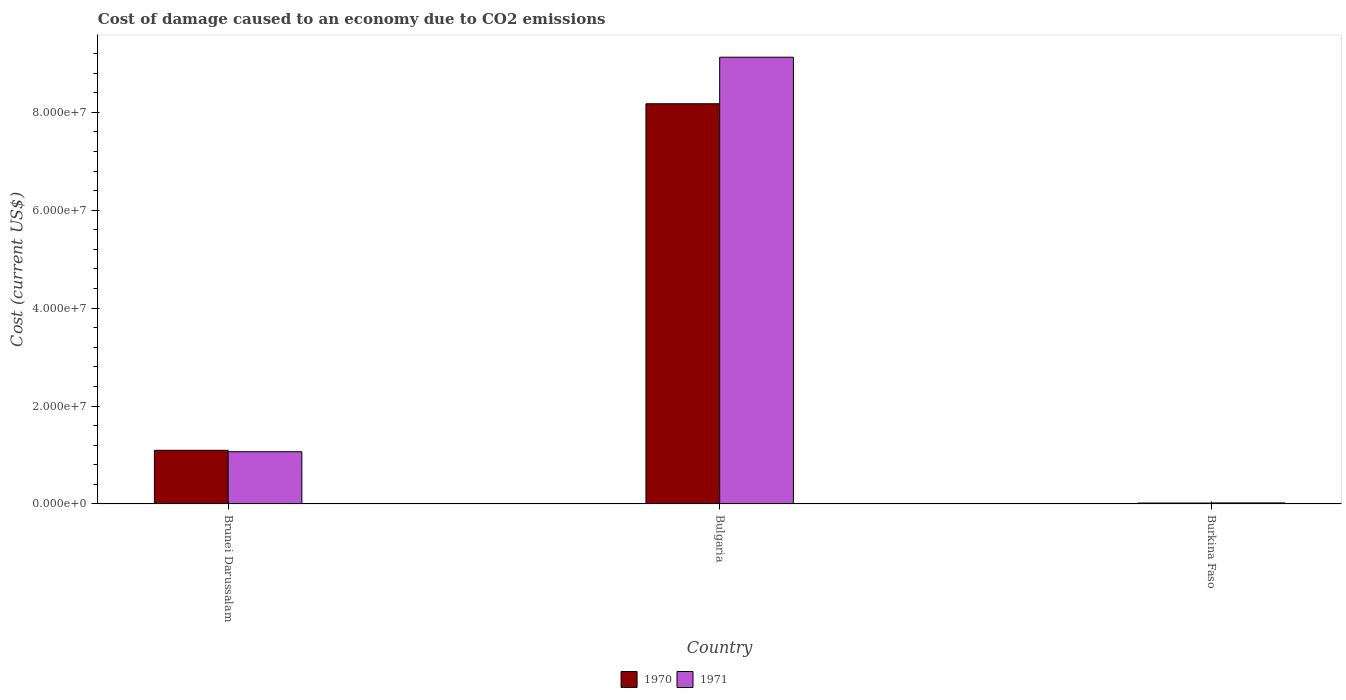What is the label of the 3rd group of bars from the left?
Provide a short and direct response. Burkina Faso. In how many cases, is the number of bars for a given country not equal to the number of legend labels?
Provide a succinct answer. 0. What is the cost of damage caused due to CO2 emissisons in 1971 in Bulgaria?
Give a very brief answer. 9.12e+07. Across all countries, what is the maximum cost of damage caused due to CO2 emissisons in 1970?
Offer a very short reply. 8.17e+07. Across all countries, what is the minimum cost of damage caused due to CO2 emissisons in 1970?
Make the answer very short. 1.91e+05. In which country was the cost of damage caused due to CO2 emissisons in 1971 minimum?
Give a very brief answer. Burkina Faso. What is the total cost of damage caused due to CO2 emissisons in 1971 in the graph?
Offer a terse response. 1.02e+08. What is the difference between the cost of damage caused due to CO2 emissisons in 1971 in Brunei Darussalam and that in Burkina Faso?
Provide a succinct answer. 1.05e+07. What is the difference between the cost of damage caused due to CO2 emissisons in 1971 in Brunei Darussalam and the cost of damage caused due to CO2 emissisons in 1970 in Bulgaria?
Make the answer very short. -7.11e+07. What is the average cost of damage caused due to CO2 emissisons in 1971 per country?
Provide a succinct answer. 3.40e+07. What is the difference between the cost of damage caused due to CO2 emissisons of/in 1970 and cost of damage caused due to CO2 emissisons of/in 1971 in Bulgaria?
Your answer should be very brief. -9.51e+06. What is the ratio of the cost of damage caused due to CO2 emissisons in 1971 in Bulgaria to that in Burkina Faso?
Provide a short and direct response. 427.68. What is the difference between the highest and the second highest cost of damage caused due to CO2 emissisons in 1971?
Your answer should be compact. 8.06e+07. What is the difference between the highest and the lowest cost of damage caused due to CO2 emissisons in 1970?
Offer a terse response. 8.16e+07. Is the sum of the cost of damage caused due to CO2 emissisons in 1970 in Bulgaria and Burkina Faso greater than the maximum cost of damage caused due to CO2 emissisons in 1971 across all countries?
Keep it short and to the point. No. What does the 2nd bar from the right in Brunei Darussalam represents?
Ensure brevity in your answer.  1970. How many bars are there?
Your answer should be compact. 6. What is the difference between two consecutive major ticks on the Y-axis?
Provide a short and direct response. 2.00e+07. Does the graph contain grids?
Your answer should be very brief. No. Where does the legend appear in the graph?
Make the answer very short. Bottom center. How are the legend labels stacked?
Make the answer very short. Horizontal. What is the title of the graph?
Offer a terse response. Cost of damage caused to an economy due to CO2 emissions. What is the label or title of the X-axis?
Your response must be concise. Country. What is the label or title of the Y-axis?
Make the answer very short. Cost (current US$). What is the Cost (current US$) of 1970 in Brunei Darussalam?
Keep it short and to the point. 1.10e+07. What is the Cost (current US$) of 1971 in Brunei Darussalam?
Ensure brevity in your answer.  1.07e+07. What is the Cost (current US$) in 1970 in Bulgaria?
Give a very brief answer. 8.17e+07. What is the Cost (current US$) of 1971 in Bulgaria?
Keep it short and to the point. 9.12e+07. What is the Cost (current US$) in 1970 in Burkina Faso?
Make the answer very short. 1.91e+05. What is the Cost (current US$) of 1971 in Burkina Faso?
Keep it short and to the point. 2.13e+05. Across all countries, what is the maximum Cost (current US$) of 1970?
Give a very brief answer. 8.17e+07. Across all countries, what is the maximum Cost (current US$) in 1971?
Provide a short and direct response. 9.12e+07. Across all countries, what is the minimum Cost (current US$) in 1970?
Give a very brief answer. 1.91e+05. Across all countries, what is the minimum Cost (current US$) of 1971?
Keep it short and to the point. 2.13e+05. What is the total Cost (current US$) of 1970 in the graph?
Your answer should be compact. 9.29e+07. What is the total Cost (current US$) of 1971 in the graph?
Make the answer very short. 1.02e+08. What is the difference between the Cost (current US$) of 1970 in Brunei Darussalam and that in Bulgaria?
Your response must be concise. -7.08e+07. What is the difference between the Cost (current US$) of 1971 in Brunei Darussalam and that in Bulgaria?
Offer a very short reply. -8.06e+07. What is the difference between the Cost (current US$) in 1970 in Brunei Darussalam and that in Burkina Faso?
Provide a succinct answer. 1.08e+07. What is the difference between the Cost (current US$) in 1971 in Brunei Darussalam and that in Burkina Faso?
Your response must be concise. 1.05e+07. What is the difference between the Cost (current US$) in 1970 in Bulgaria and that in Burkina Faso?
Your answer should be very brief. 8.16e+07. What is the difference between the Cost (current US$) in 1971 in Bulgaria and that in Burkina Faso?
Your response must be concise. 9.10e+07. What is the difference between the Cost (current US$) of 1970 in Brunei Darussalam and the Cost (current US$) of 1971 in Bulgaria?
Your answer should be compact. -8.03e+07. What is the difference between the Cost (current US$) in 1970 in Brunei Darussalam and the Cost (current US$) in 1971 in Burkina Faso?
Provide a short and direct response. 1.07e+07. What is the difference between the Cost (current US$) of 1970 in Bulgaria and the Cost (current US$) of 1971 in Burkina Faso?
Your answer should be compact. 8.15e+07. What is the average Cost (current US$) in 1970 per country?
Ensure brevity in your answer.  3.10e+07. What is the average Cost (current US$) in 1971 per country?
Offer a very short reply. 3.40e+07. What is the difference between the Cost (current US$) of 1970 and Cost (current US$) of 1971 in Brunei Darussalam?
Your answer should be very brief. 2.92e+05. What is the difference between the Cost (current US$) of 1970 and Cost (current US$) of 1971 in Bulgaria?
Your answer should be compact. -9.51e+06. What is the difference between the Cost (current US$) in 1970 and Cost (current US$) in 1971 in Burkina Faso?
Your answer should be very brief. -2.25e+04. What is the ratio of the Cost (current US$) of 1970 in Brunei Darussalam to that in Bulgaria?
Give a very brief answer. 0.13. What is the ratio of the Cost (current US$) in 1971 in Brunei Darussalam to that in Bulgaria?
Your answer should be compact. 0.12. What is the ratio of the Cost (current US$) in 1970 in Brunei Darussalam to that in Burkina Faso?
Your answer should be compact. 57.41. What is the ratio of the Cost (current US$) of 1971 in Brunei Darussalam to that in Burkina Faso?
Make the answer very short. 50. What is the ratio of the Cost (current US$) of 1970 in Bulgaria to that in Burkina Faso?
Give a very brief answer. 428.21. What is the ratio of the Cost (current US$) in 1971 in Bulgaria to that in Burkina Faso?
Ensure brevity in your answer.  427.68. What is the difference between the highest and the second highest Cost (current US$) in 1970?
Your response must be concise. 7.08e+07. What is the difference between the highest and the second highest Cost (current US$) in 1971?
Ensure brevity in your answer.  8.06e+07. What is the difference between the highest and the lowest Cost (current US$) of 1970?
Ensure brevity in your answer.  8.16e+07. What is the difference between the highest and the lowest Cost (current US$) of 1971?
Give a very brief answer. 9.10e+07. 